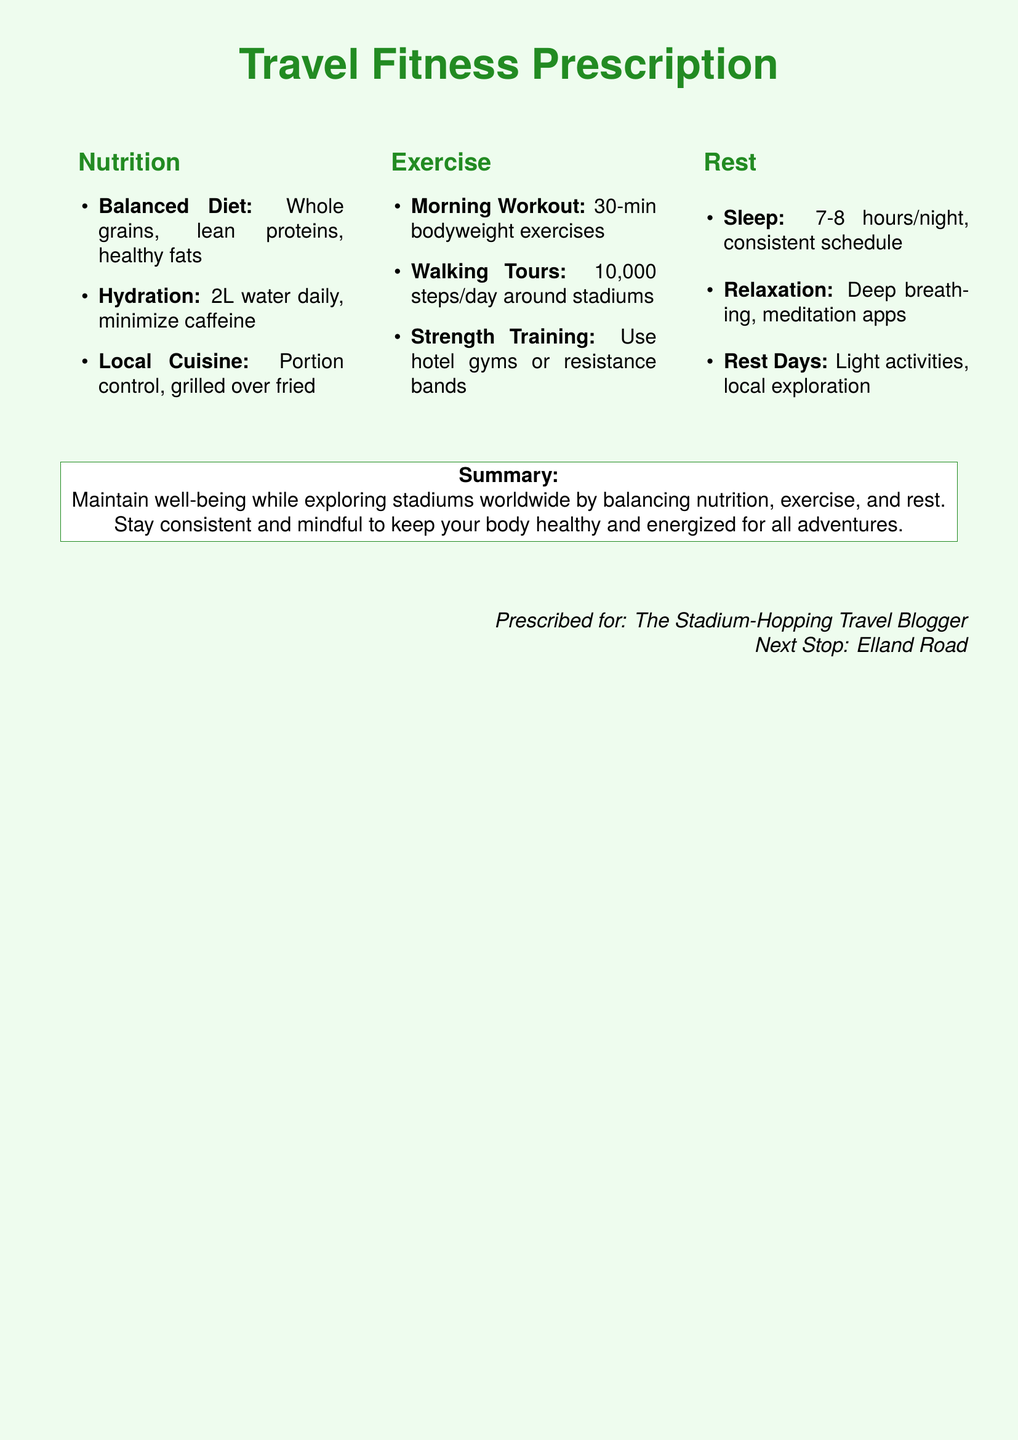What is the recommended water intake? The document specifies that the daily hydration goal is 2L of water.
Answer: 2L What type of protein is suggested for a balanced diet? The document mentions lean proteins as part of a balanced diet.
Answer: Lean proteins How many hours of sleep are advised per night? The recommended amount of sleep is stated as 7-8 hours per night.
Answer: 7-8 hours What type of physical activity is suggested for a morning workout? The document suggests bodyweight exercises for a morning workout.
Answer: Bodyweight exercises What is the recommended daily step count? The document indicates a target of 10,000 steps per day for walking tours.
Answer: 10,000 steps What relaxation technique is mentioned? The document mentions deep breathing as a relaxation technique.
Answer: Deep breathing Who is the prescription prescribed for? The document states that it is prescribed for “The Stadium-Hopping Travel Blogger.”
Answer: The Stadium-Hopping Travel Blogger What is the purpose of the prescription? The summary in the document highlights maintaining well-being while exploring stadiums worldwide.
Answer: Maintaining well-being while exploring stadiums worldwide What next destination is mentioned in the prescription? The document indicates Elland Road as the next stop.
Answer: Elland Road 